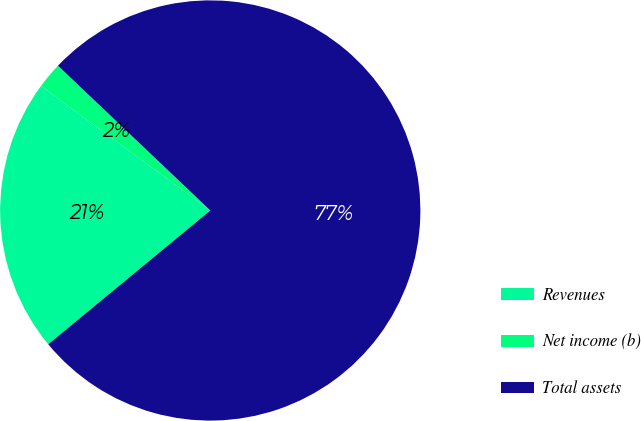Convert chart. <chart><loc_0><loc_0><loc_500><loc_500><pie_chart><fcel>Revenues<fcel>Net income (b)<fcel>Total assets<nl><fcel>21.08%<fcel>2.0%<fcel>76.91%<nl></chart> 